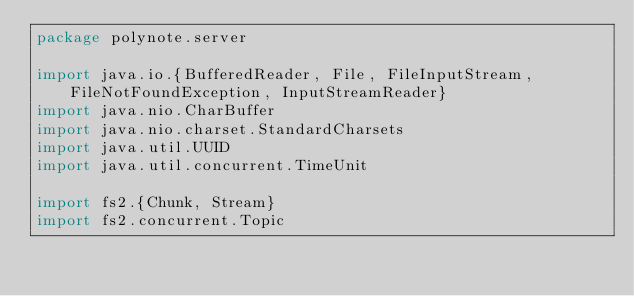<code> <loc_0><loc_0><loc_500><loc_500><_Scala_>package polynote.server

import java.io.{BufferedReader, File, FileInputStream, FileNotFoundException, InputStreamReader}
import java.nio.CharBuffer
import java.nio.charset.StandardCharsets
import java.util.UUID
import java.util.concurrent.TimeUnit

import fs2.{Chunk, Stream}
import fs2.concurrent.Topic</code> 